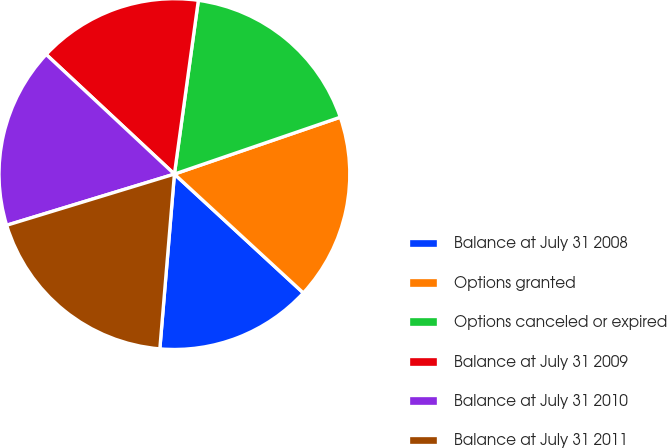Convert chart to OTSL. <chart><loc_0><loc_0><loc_500><loc_500><pie_chart><fcel>Balance at July 31 2008<fcel>Options granted<fcel>Options canceled or expired<fcel>Balance at July 31 2009<fcel>Balance at July 31 2010<fcel>Balance at July 31 2011<nl><fcel>14.47%<fcel>17.11%<fcel>17.56%<fcel>15.23%<fcel>16.66%<fcel>18.96%<nl></chart> 